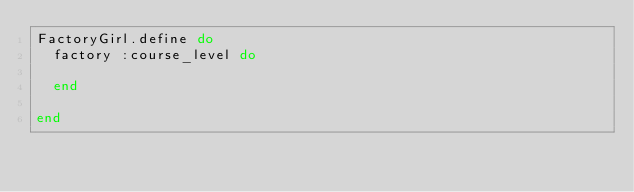<code> <loc_0><loc_0><loc_500><loc_500><_Ruby_>FactoryGirl.define do
  factory :course_level do
    
  end

end
</code> 